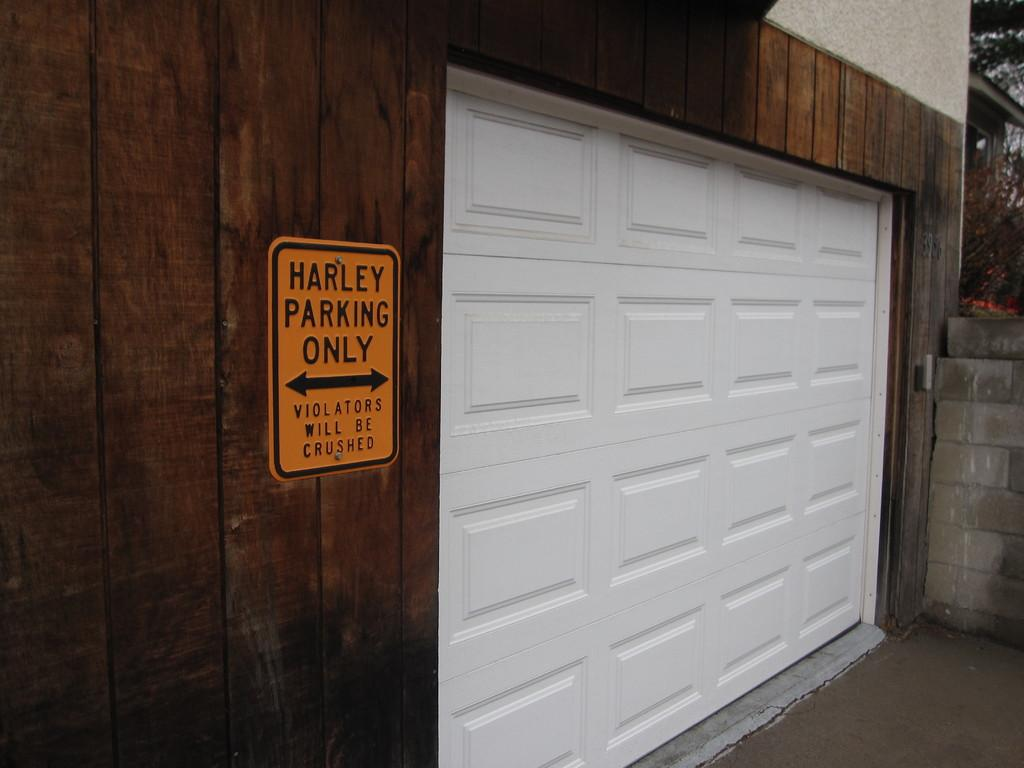What type of structure is shown in the image? The image depicts a building. What specific feature of the building can be seen? There is a home garage door visible. Is there is any textual information in the image? Yes, there is a board with text in the image. What type of natural elements are present in the image? Trees are present in the image. Are there any other buildings visible in the image? Yes, there is another house in the top right corner of the image. What color is the sofa in the image? There is no sofa present in the image. What type of test is being conducted in the image? There is no test being conducted in the image. 